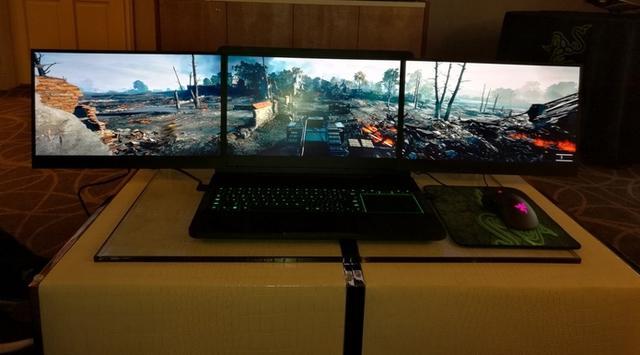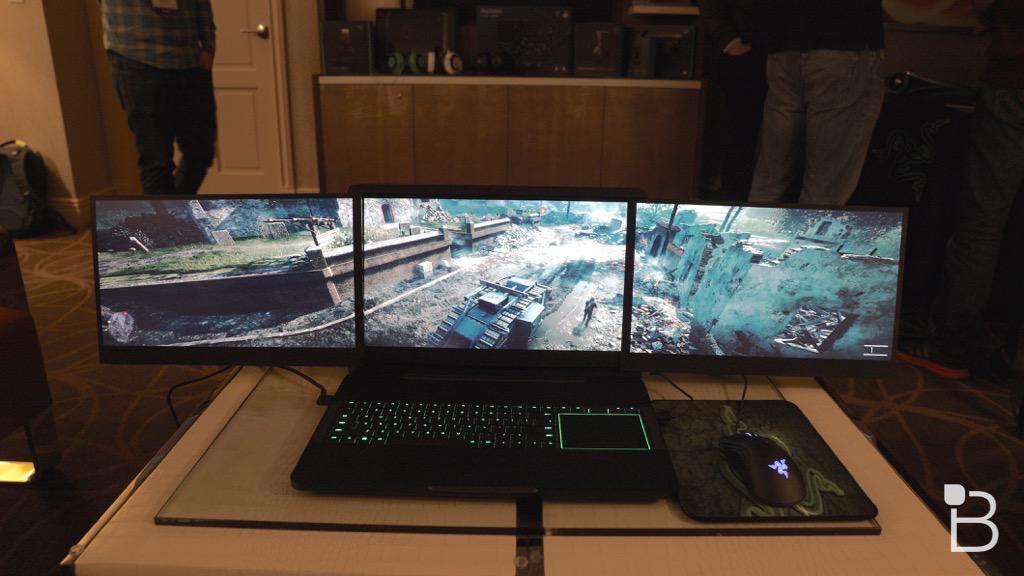The first image is the image on the left, the second image is the image on the right. Considering the images on both sides, is "Each image shows a mostly head-on view of a triple-display laptop on a brownish desk, projecting a video game scene." valid? Answer yes or no. Yes. The first image is the image on the left, the second image is the image on the right. Assess this claim about the two images: "The computer mouse in one of the image has a purple triangle light on it.". Correct or not? Answer yes or no. Yes. 